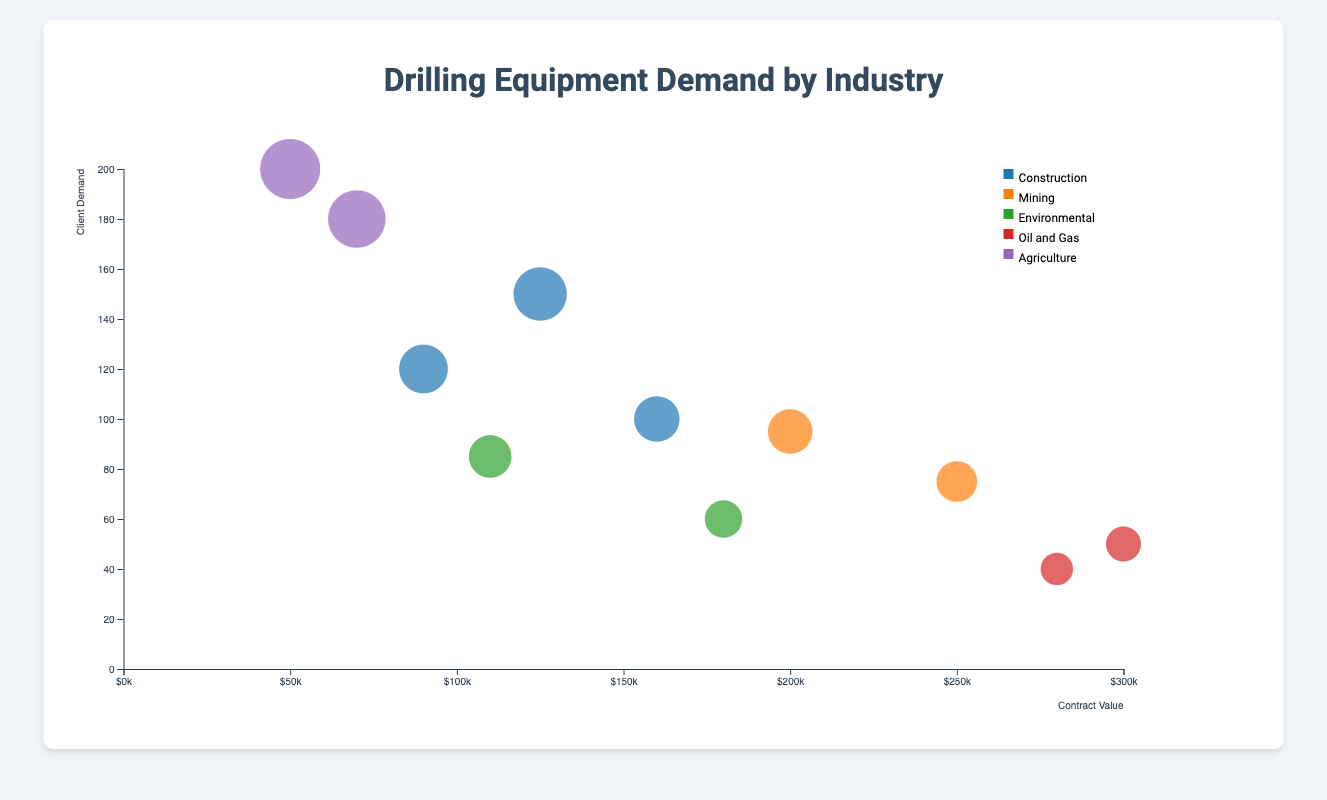What industry has the highest demand for drilling equipment? By observing the y-axis (client demand), we look for the tallest bubble. The tallest bubble corresponds to the Agriculture industry, specifically Post Hole Diggers.
Answer: Agriculture What is the contract value range displayed on the x-axis? The x-axis shows contract values ranging from 0 to a bit over 300,000. This can be inferred from the axis ticks and maximum bubble positions.
Answer: 0 to 300,000 Which equipment type has the highest contract value, and what is its demand? The bubble farthest to the right on the x-axis represents the highest contract value. This is the Rotary Rig in the Oil and Gas industry, with a contract value of 300,000 and a client demand of 50.
Answer: Rotary Rig, 50 How does the demand for Post Hole Diggers compare to Rotary Drills? Post Hole Diggers in the Agriculture industry show a client demand of 200, while Rotary Drills in the Construction industry have a demand of 150. Post Hole Diggers have higher demand.
Answer: Post Hole Diggers have higher demand Which equipment type in the Environmental industry has a higher contract value? In the Environmental industry, Sonic Drills have a contract value of 180,000, while Auger Drills have a contract value of 110,000. Sonic Drills have a higher contract value.
Answer: Sonic Drills What is the total contract value for Construction industry equipment types? Summing up the contract values for Rotary Drills (125,000), Percussion Drills (90,000), and Coring Rigs (160,000) results in 125,000 + 90,000 + 160,000 = 375,000.
Answer: 375,000 Rank the industries based on their highest client demand for a single equipment type. By comparing the highest demands for a single equipment type in each industry: Agriculture (200 for Post Hole Diggers), Construction (150 for Rotary Drills), Mining (95 for Exploration Rigs), Environmental (85 for Auger Drills), and Oil and Gas (50 for Rotary Rigs). The rank is Agriculture > Construction > Mining > Environmental > Oil and Gas.
Answer: Agriculture > Construction > Mining > Environmental > Oil and Gas Which industry has the least client demand for its equipment types? Observing bubbles with the lowest position on the y-axis indicates the Oil and Gas industry, with the highest demand of just 50 (Rotary Rigs) and 40 (Directional Drills).
Answer: Oil and Gas What is the average client demand for equipment in the Construction industry? The client demands are 150 (Rotary Drills), 120 (Percussion Drills), and 100 (Coring Rigs). The average demand is (150 + 120 + 100)/3 = 123.33.
Answer: 123.33 